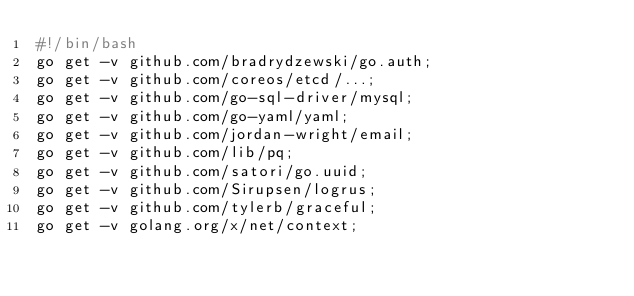<code> <loc_0><loc_0><loc_500><loc_500><_Bash_>#!/bin/bash
go get -v github.com/bradrydzewski/go.auth;
go get -v github.com/coreos/etcd/...;
go get -v github.com/go-sql-driver/mysql;
go get -v github.com/go-yaml/yaml;
go get -v github.com/jordan-wright/email;
go get -v github.com/lib/pq;
go get -v github.com/satori/go.uuid;
go get -v github.com/Sirupsen/logrus;
go get -v github.com/tylerb/graceful;
go get -v golang.org/x/net/context;
</code> 